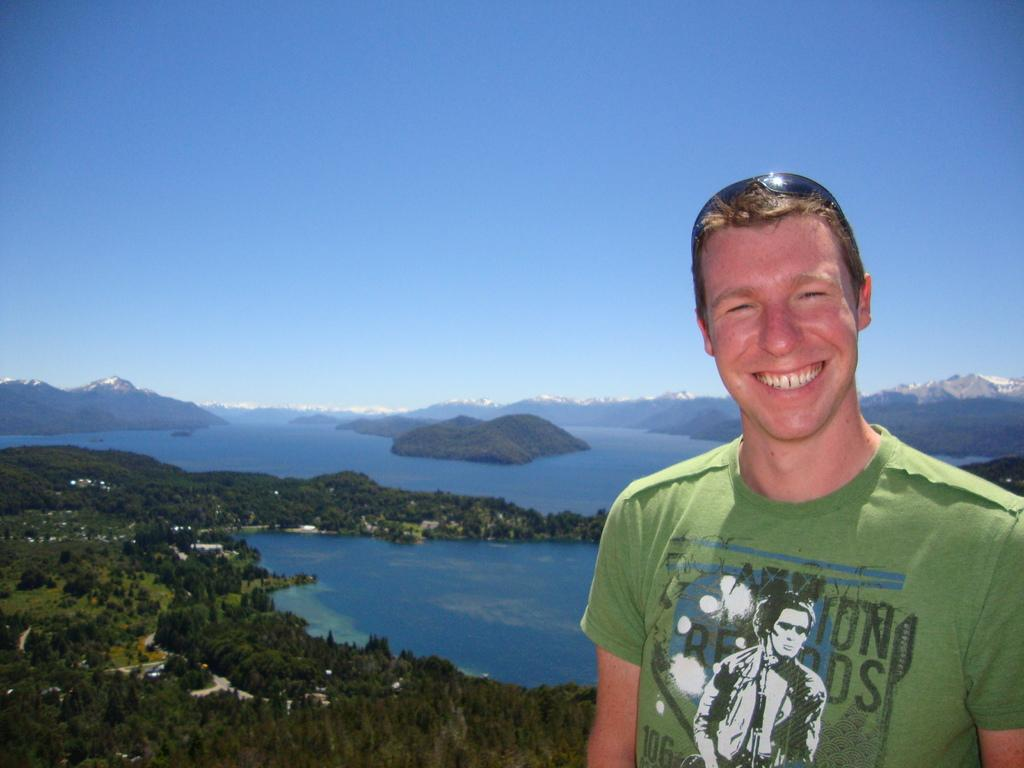What is the main subject of the image? There is a person in the image. What type of natural environment is depicted in the image? The image features trees, hills, water, mountains, and the sky. Can you describe the landscape in the image? The image shows a landscape with trees, hills, water, and mountains. What type of milk is the person drinking in the image? There is no milk present in the image, and the person's actions are not described. What riddle is the person trying to solve in the image? There is no riddle present in the image, and the person's actions are not described. 